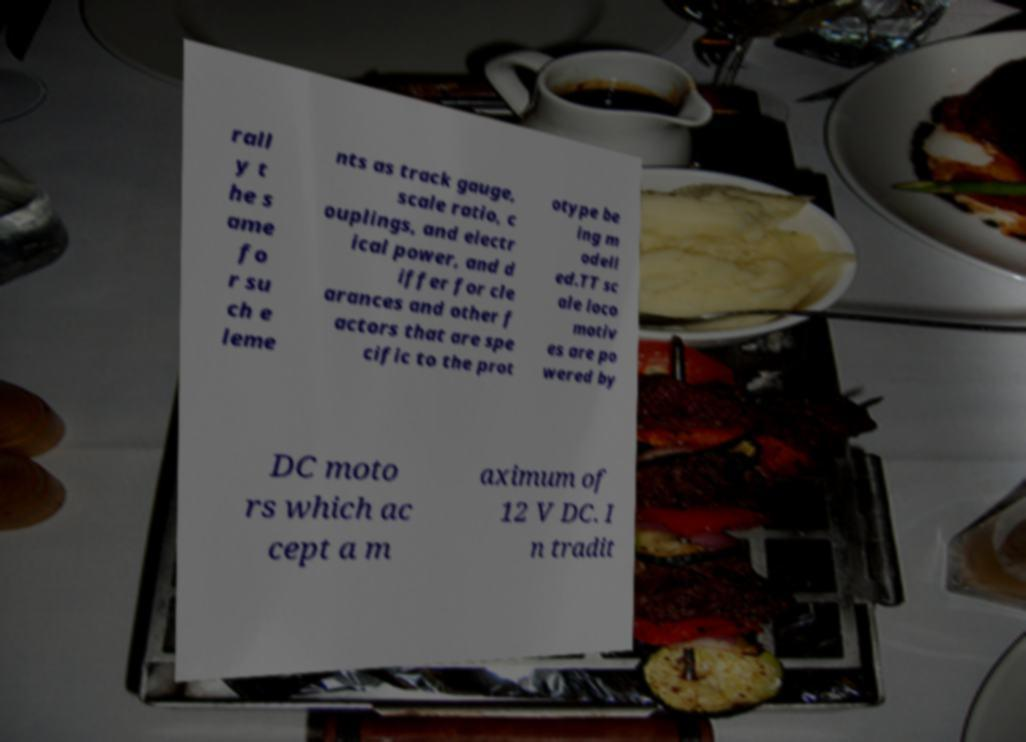Could you assist in decoding the text presented in this image and type it out clearly? rall y t he s ame fo r su ch e leme nts as track gauge, scale ratio, c ouplings, and electr ical power, and d iffer for cle arances and other f actors that are spe cific to the prot otype be ing m odell ed.TT sc ale loco motiv es are po wered by DC moto rs which ac cept a m aximum of 12 V DC. I n tradit 